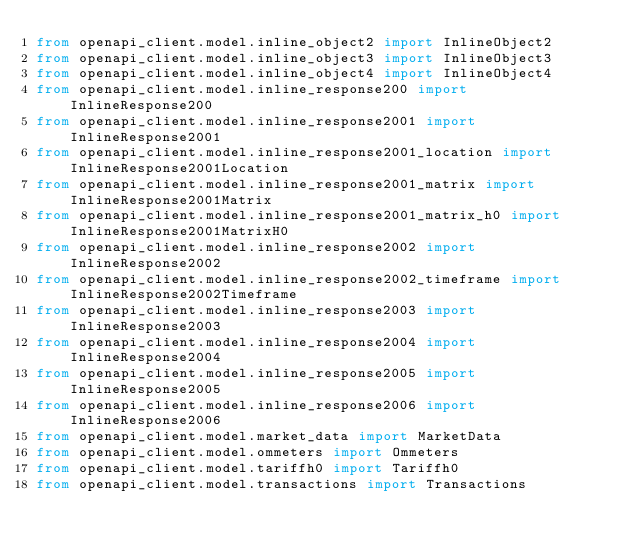<code> <loc_0><loc_0><loc_500><loc_500><_Python_>from openapi_client.model.inline_object2 import InlineObject2
from openapi_client.model.inline_object3 import InlineObject3
from openapi_client.model.inline_object4 import InlineObject4
from openapi_client.model.inline_response200 import InlineResponse200
from openapi_client.model.inline_response2001 import InlineResponse2001
from openapi_client.model.inline_response2001_location import InlineResponse2001Location
from openapi_client.model.inline_response2001_matrix import InlineResponse2001Matrix
from openapi_client.model.inline_response2001_matrix_h0 import InlineResponse2001MatrixH0
from openapi_client.model.inline_response2002 import InlineResponse2002
from openapi_client.model.inline_response2002_timeframe import InlineResponse2002Timeframe
from openapi_client.model.inline_response2003 import InlineResponse2003
from openapi_client.model.inline_response2004 import InlineResponse2004
from openapi_client.model.inline_response2005 import InlineResponse2005
from openapi_client.model.inline_response2006 import InlineResponse2006
from openapi_client.model.market_data import MarketData
from openapi_client.model.ommeters import Ommeters
from openapi_client.model.tariffh0 import Tariffh0
from openapi_client.model.transactions import Transactions
</code> 